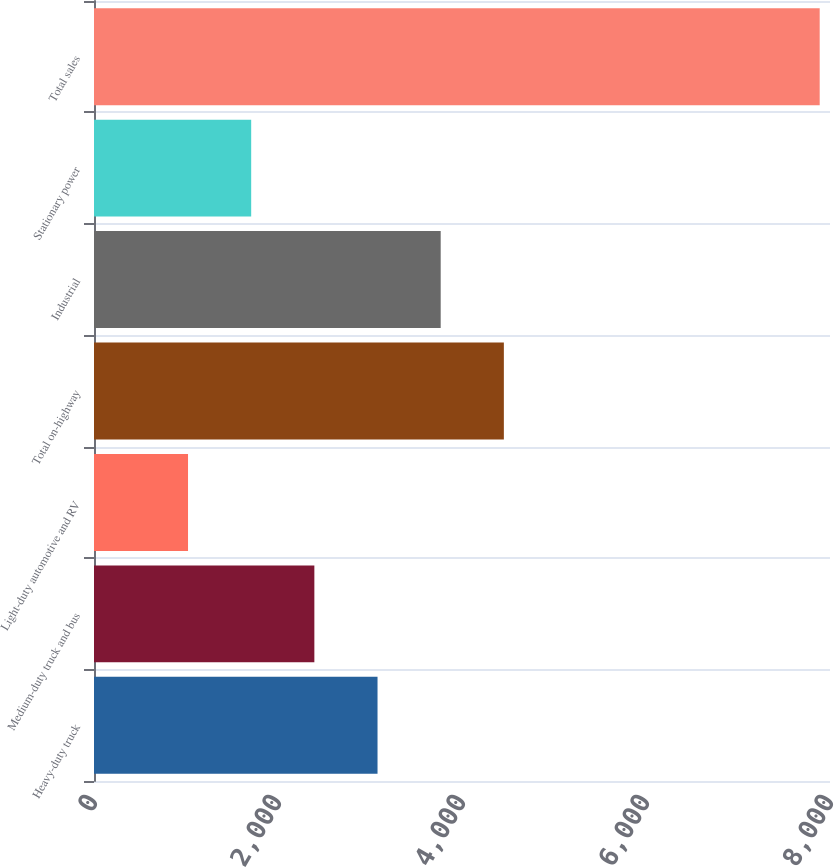Convert chart. <chart><loc_0><loc_0><loc_500><loc_500><bar_chart><fcel>Heavy-duty truck<fcel>Medium-duty truck and bus<fcel>Light-duty automotive and RV<fcel>Total on-highway<fcel>Industrial<fcel>Stationary power<fcel>Total sales<nl><fcel>3081.8<fcel>2395.2<fcel>1022<fcel>4455<fcel>3768.4<fcel>1708.6<fcel>7888<nl></chart> 